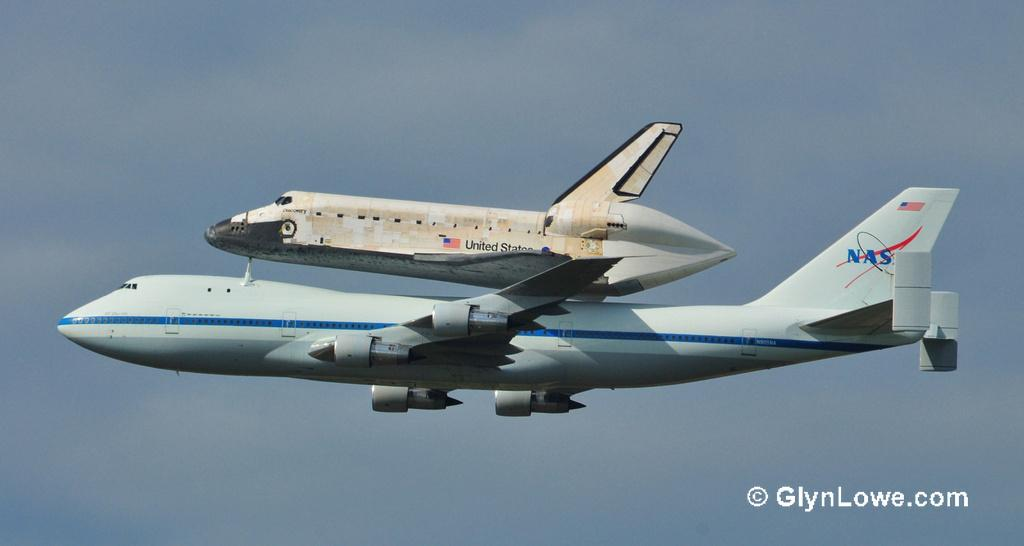<image>
Offer a succinct explanation of the picture presented. A NASA airplane accompanies a United States space shuttle. 